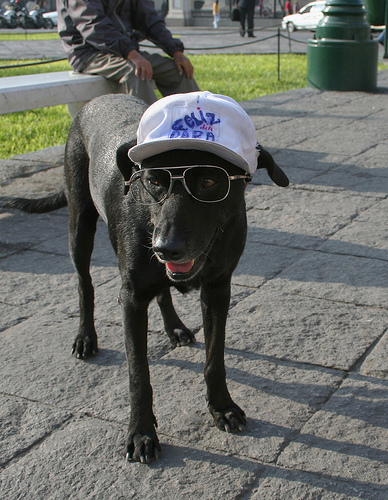What impression does the dog's attire give about its personality or the setting it's in? The dog's attire, consisting of sunglasses and a branded cap, suggests a fun-loving and possibly playful personality. It also hints at a casual, outdoor setting where such accessories might be part of a humorous or endearing scene, perhaps at a park or a pet-themed event. 